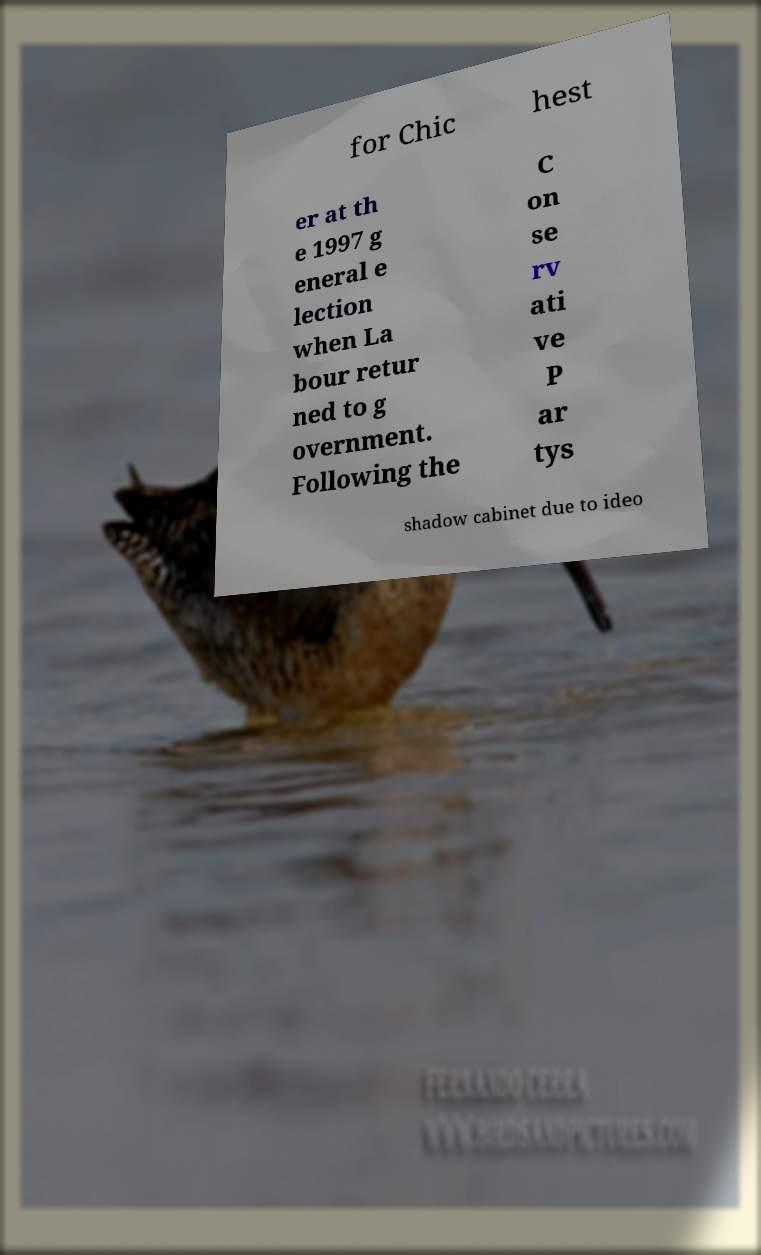I need the written content from this picture converted into text. Can you do that? for Chic hest er at th e 1997 g eneral e lection when La bour retur ned to g overnment. Following the C on se rv ati ve P ar tys shadow cabinet due to ideo 